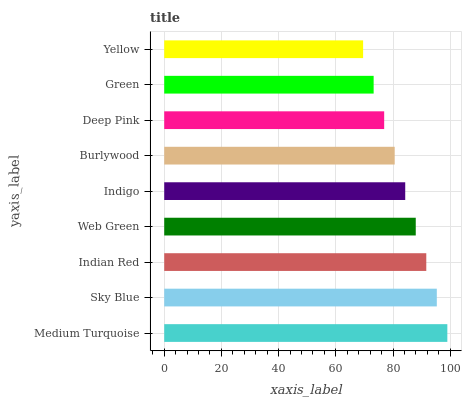Is Yellow the minimum?
Answer yes or no. Yes. Is Medium Turquoise the maximum?
Answer yes or no. Yes. Is Sky Blue the minimum?
Answer yes or no. No. Is Sky Blue the maximum?
Answer yes or no. No. Is Medium Turquoise greater than Sky Blue?
Answer yes or no. Yes. Is Sky Blue less than Medium Turquoise?
Answer yes or no. Yes. Is Sky Blue greater than Medium Turquoise?
Answer yes or no. No. Is Medium Turquoise less than Sky Blue?
Answer yes or no. No. Is Indigo the high median?
Answer yes or no. Yes. Is Indigo the low median?
Answer yes or no. Yes. Is Indian Red the high median?
Answer yes or no. No. Is Medium Turquoise the low median?
Answer yes or no. No. 